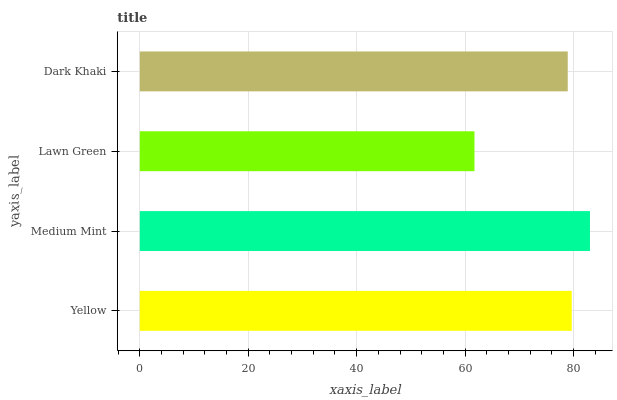Is Lawn Green the minimum?
Answer yes or no. Yes. Is Medium Mint the maximum?
Answer yes or no. Yes. Is Medium Mint the minimum?
Answer yes or no. No. Is Lawn Green the maximum?
Answer yes or no. No. Is Medium Mint greater than Lawn Green?
Answer yes or no. Yes. Is Lawn Green less than Medium Mint?
Answer yes or no. Yes. Is Lawn Green greater than Medium Mint?
Answer yes or no. No. Is Medium Mint less than Lawn Green?
Answer yes or no. No. Is Yellow the high median?
Answer yes or no. Yes. Is Dark Khaki the low median?
Answer yes or no. Yes. Is Medium Mint the high median?
Answer yes or no. No. Is Lawn Green the low median?
Answer yes or no. No. 